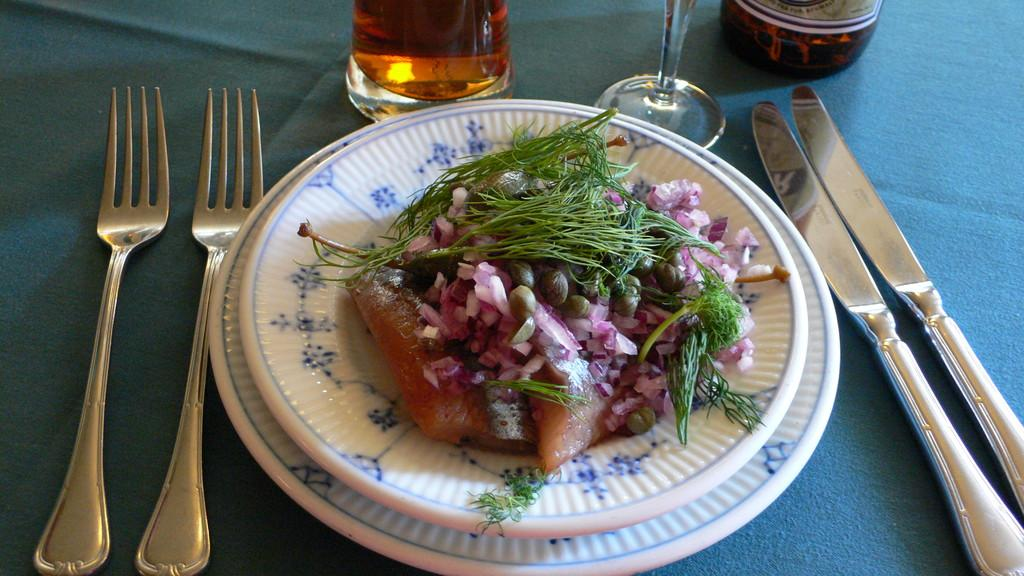What type of utensils can be seen in the image? There are forks and knives in the image. What is the color of the plate that holds the food item? The plate is white. What type of containers are present in the image? There are glasses in the image. What other objects can be seen on the surface in the image? There are other objects on the surface, but their specific details are not mentioned in the provided facts. What type of train can be seen in the image? There is no train present in the image. What type of work is being done in the image? The image does not depict any work being done. 